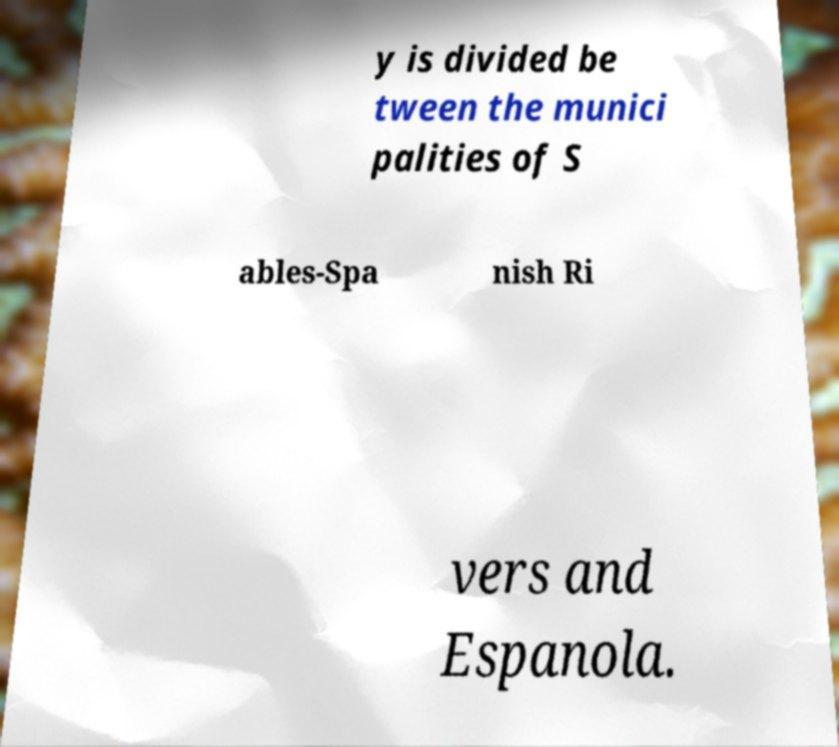For documentation purposes, I need the text within this image transcribed. Could you provide that? y is divided be tween the munici palities of S ables-Spa nish Ri vers and Espanola. 